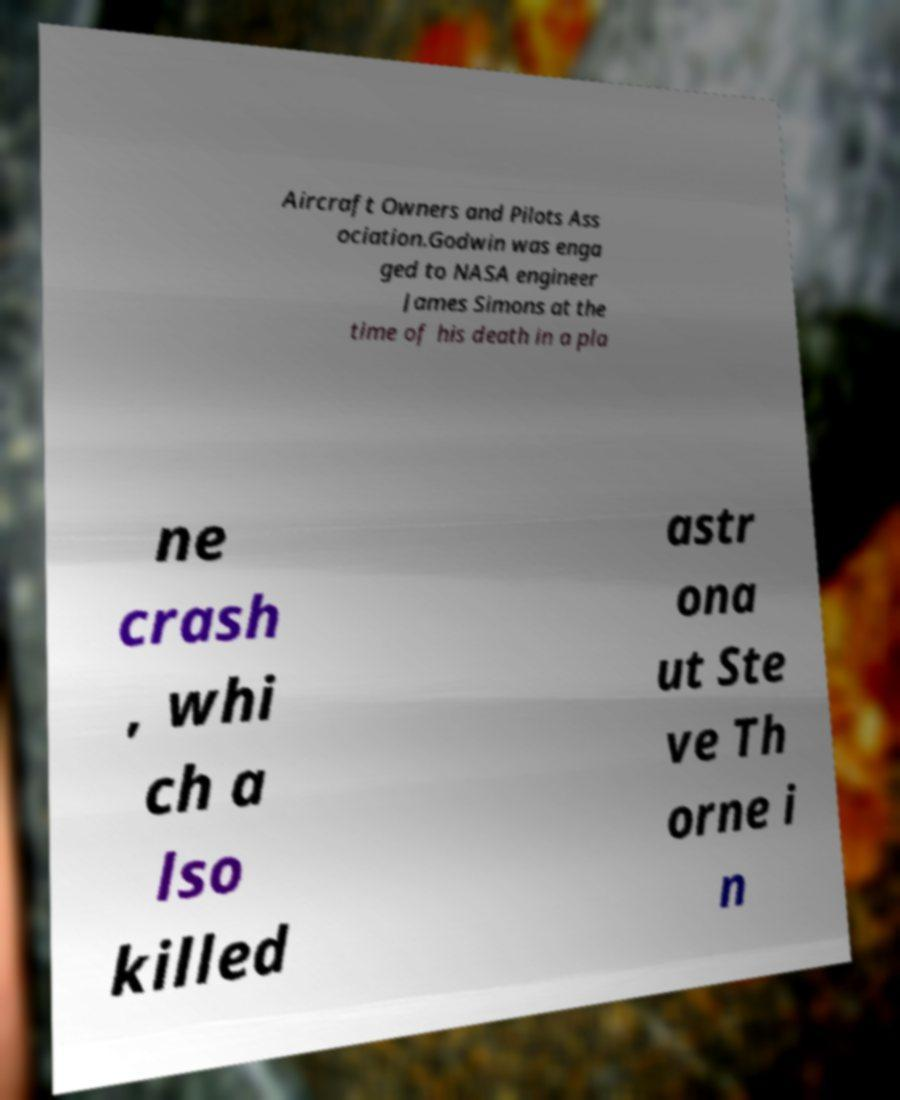What messages or text are displayed in this image? I need them in a readable, typed format. Aircraft Owners and Pilots Ass ociation.Godwin was enga ged to NASA engineer James Simons at the time of his death in a pla ne crash , whi ch a lso killed astr ona ut Ste ve Th orne i n 